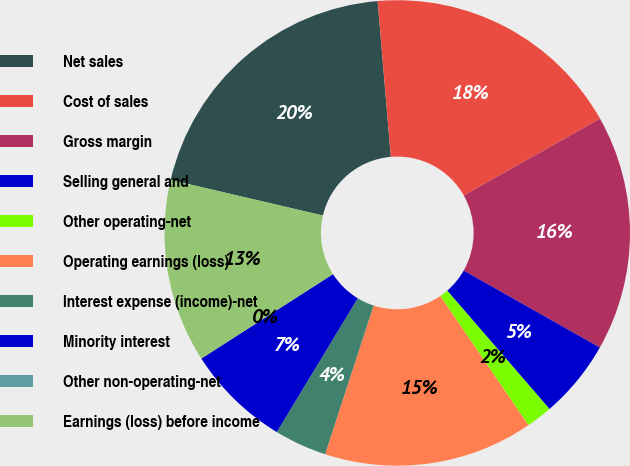<chart> <loc_0><loc_0><loc_500><loc_500><pie_chart><fcel>Net sales<fcel>Cost of sales<fcel>Gross margin<fcel>Selling general and<fcel>Other operating-net<fcel>Operating earnings (loss)<fcel>Interest expense (income)-net<fcel>Minority interest<fcel>Other non-operating-net<fcel>Earnings (loss) before income<nl><fcel>20.0%<fcel>18.18%<fcel>16.36%<fcel>5.46%<fcel>1.82%<fcel>14.54%<fcel>3.64%<fcel>7.27%<fcel>0.0%<fcel>12.73%<nl></chart> 